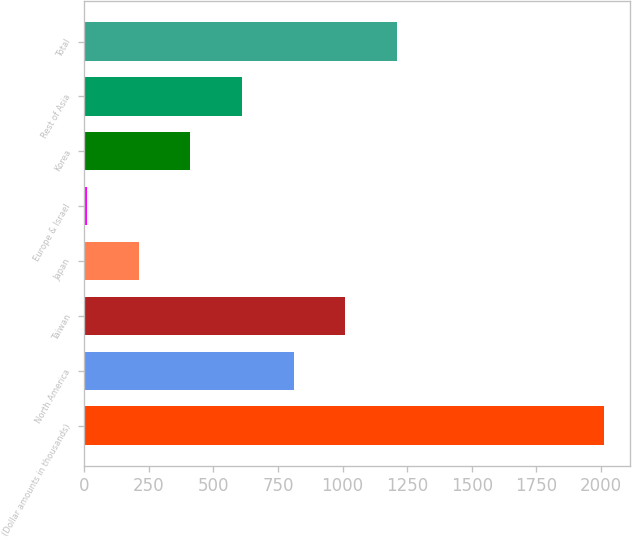<chart> <loc_0><loc_0><loc_500><loc_500><bar_chart><fcel>(Dollar amounts in thousands)<fcel>North America<fcel>Taiwan<fcel>Japan<fcel>Europe & Israel<fcel>Korea<fcel>Rest of Asia<fcel>Total<nl><fcel>2011<fcel>811<fcel>1011<fcel>211<fcel>11<fcel>411<fcel>611<fcel>1211<nl></chart> 